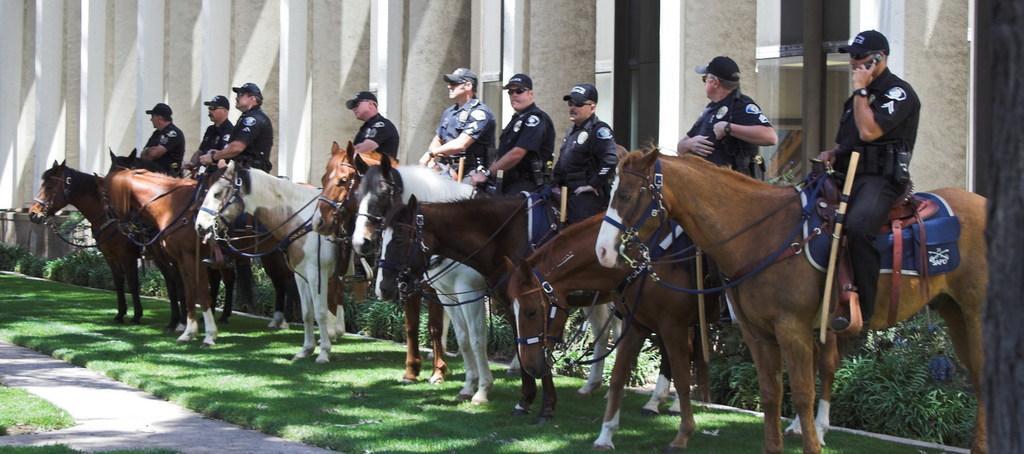How would you summarize this image in a sentence or two? In the given image i can see a people sitting on the horses,plants,grass,building and rod. 